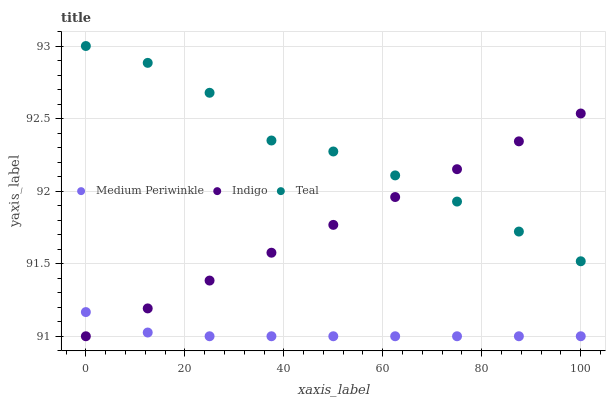Does Medium Periwinkle have the minimum area under the curve?
Answer yes or no. Yes. Does Teal have the maximum area under the curve?
Answer yes or no. Yes. Does Teal have the minimum area under the curve?
Answer yes or no. No. Does Medium Periwinkle have the maximum area under the curve?
Answer yes or no. No. Is Indigo the smoothest?
Answer yes or no. Yes. Is Teal the roughest?
Answer yes or no. Yes. Is Medium Periwinkle the smoothest?
Answer yes or no. No. Is Medium Periwinkle the roughest?
Answer yes or no. No. Does Indigo have the lowest value?
Answer yes or no. Yes. Does Teal have the lowest value?
Answer yes or no. No. Does Teal have the highest value?
Answer yes or no. Yes. Does Medium Periwinkle have the highest value?
Answer yes or no. No. Is Medium Periwinkle less than Teal?
Answer yes or no. Yes. Is Teal greater than Medium Periwinkle?
Answer yes or no. Yes. Does Indigo intersect Teal?
Answer yes or no. Yes. Is Indigo less than Teal?
Answer yes or no. No. Is Indigo greater than Teal?
Answer yes or no. No. Does Medium Periwinkle intersect Teal?
Answer yes or no. No. 